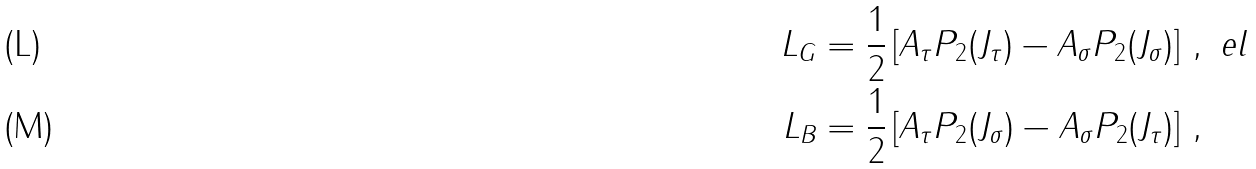<formula> <loc_0><loc_0><loc_500><loc_500>L _ { G } & = \frac { 1 } { 2 } \left [ A _ { \tau } P _ { 2 } ( J _ { \tau } ) - A _ { \sigma } P _ { 2 } ( J _ { \sigma } ) \right ] \, , \ e l \\ L _ { B } & = \frac { 1 } { 2 } \left [ A _ { \tau } P _ { 2 } ( J _ { \sigma } ) - A _ { \sigma } P _ { 2 } ( J _ { \tau } ) \right ] \, ,</formula> 